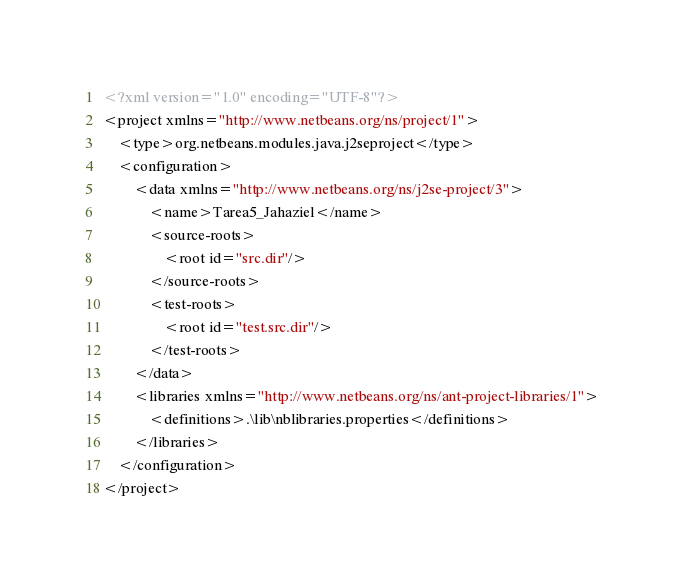Convert code to text. <code><loc_0><loc_0><loc_500><loc_500><_XML_><?xml version="1.0" encoding="UTF-8"?>
<project xmlns="http://www.netbeans.org/ns/project/1">
    <type>org.netbeans.modules.java.j2seproject</type>
    <configuration>
        <data xmlns="http://www.netbeans.org/ns/j2se-project/3">
            <name>Tarea5_Jahaziel</name>
            <source-roots>
                <root id="src.dir"/>
            </source-roots>
            <test-roots>
                <root id="test.src.dir"/>
            </test-roots>
        </data>
        <libraries xmlns="http://www.netbeans.org/ns/ant-project-libraries/1">
            <definitions>.\lib\nblibraries.properties</definitions>
        </libraries>
    </configuration>
</project>
</code> 